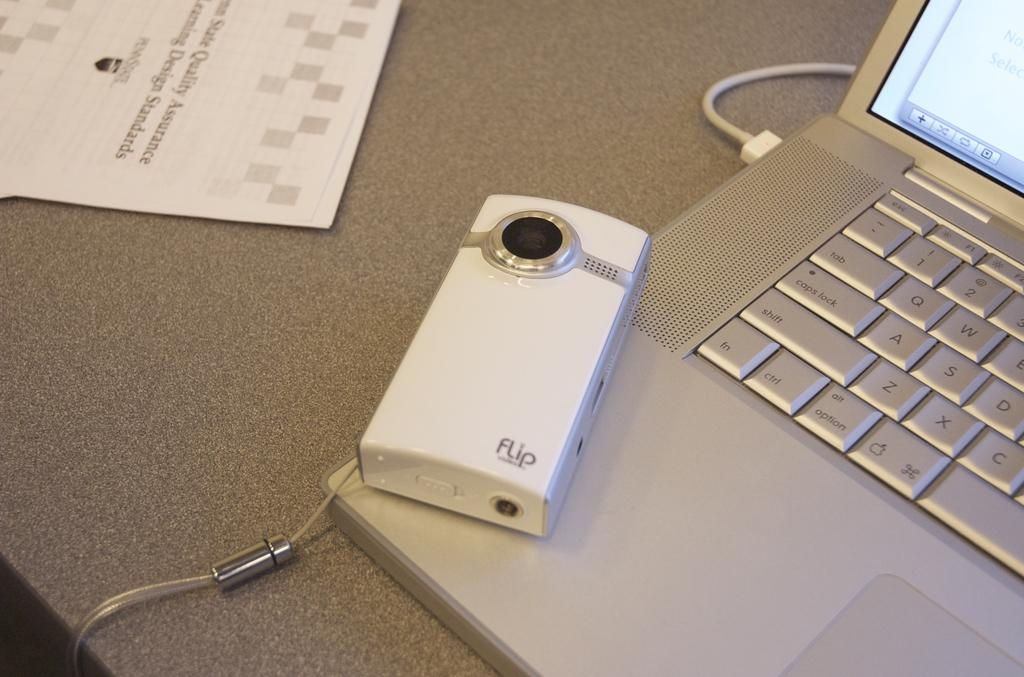<image>
Describe the image concisely. A white Flip branded camera sitting on the keyboard of a silver laptop computer. 